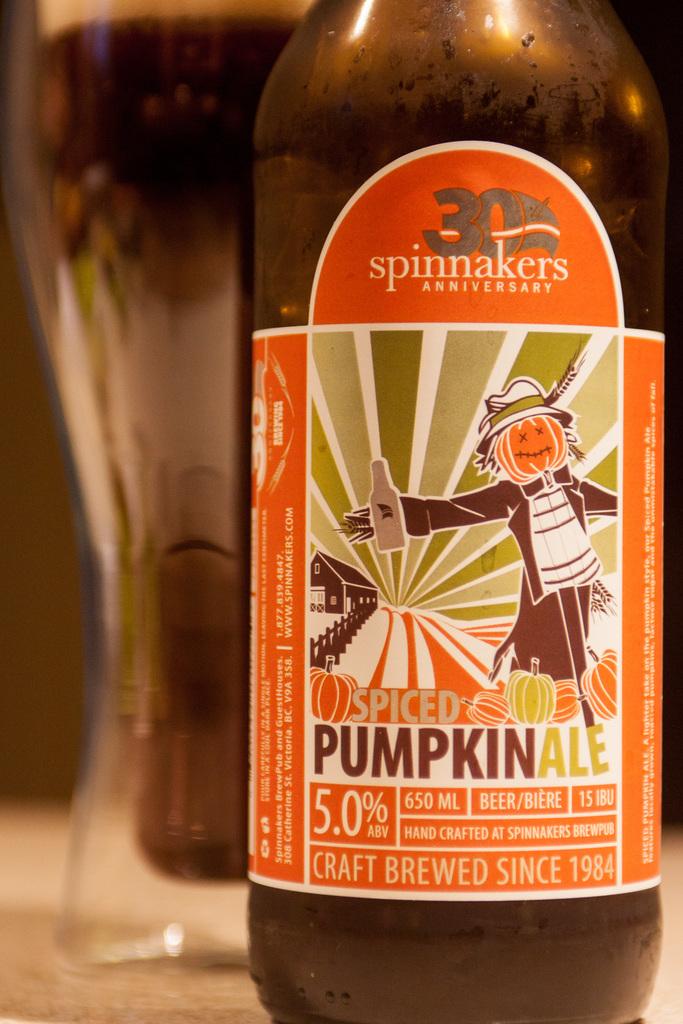How many ml is this bottle?
Offer a very short reply. 650. What flavor of ale is this?
Provide a succinct answer. Pumpkin. 